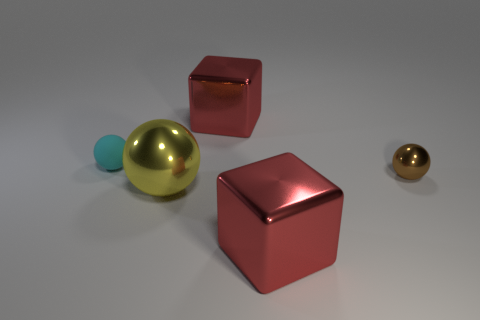Add 3 metallic blocks. How many objects exist? 8 Subtract all brown balls. How many balls are left? 2 Subtract all shiny spheres. How many spheres are left? 1 Subtract all cubes. How many objects are left? 3 Add 3 big yellow objects. How many big yellow objects are left? 4 Add 1 large brown cylinders. How many large brown cylinders exist? 1 Subtract 0 green cylinders. How many objects are left? 5 Subtract 3 balls. How many balls are left? 0 Subtract all red balls. Subtract all red cylinders. How many balls are left? 3 Subtract all cyan balls. How many blue blocks are left? 0 